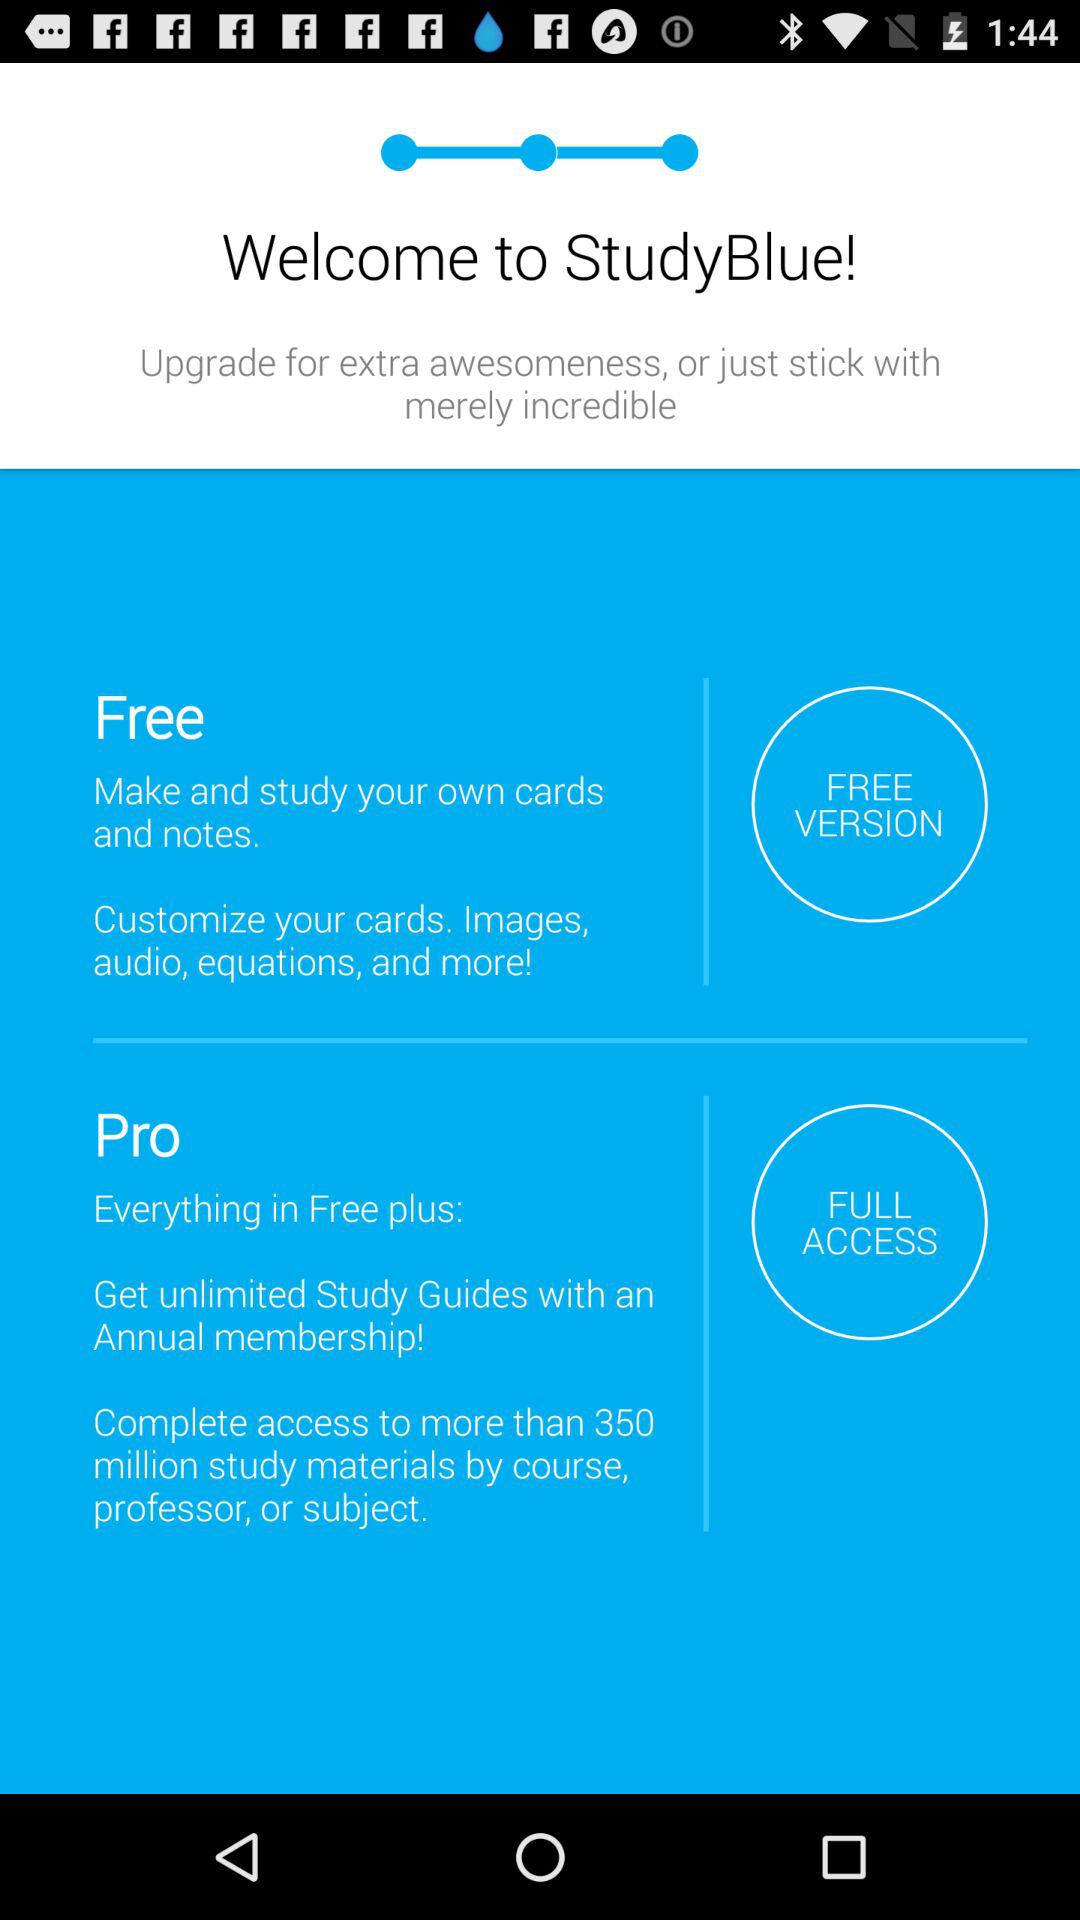How many study materials are free to access in the pro version? There are more than 350 million study materials available free to access. 